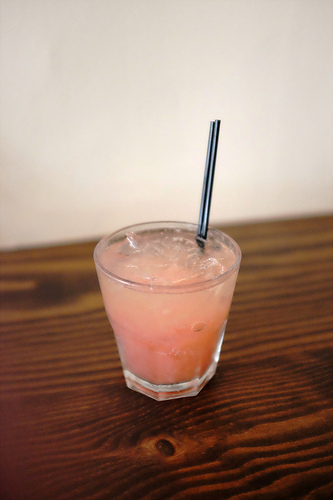<image>
Is the straw on the table? No. The straw is not positioned on the table. They may be near each other, but the straw is not supported by or resting on top of the table. Is the straw behind the drink? No. The straw is not behind the drink. From this viewpoint, the straw appears to be positioned elsewhere in the scene. Is there a glass next to the straw? No. The glass is not positioned next to the straw. They are located in different areas of the scene. 